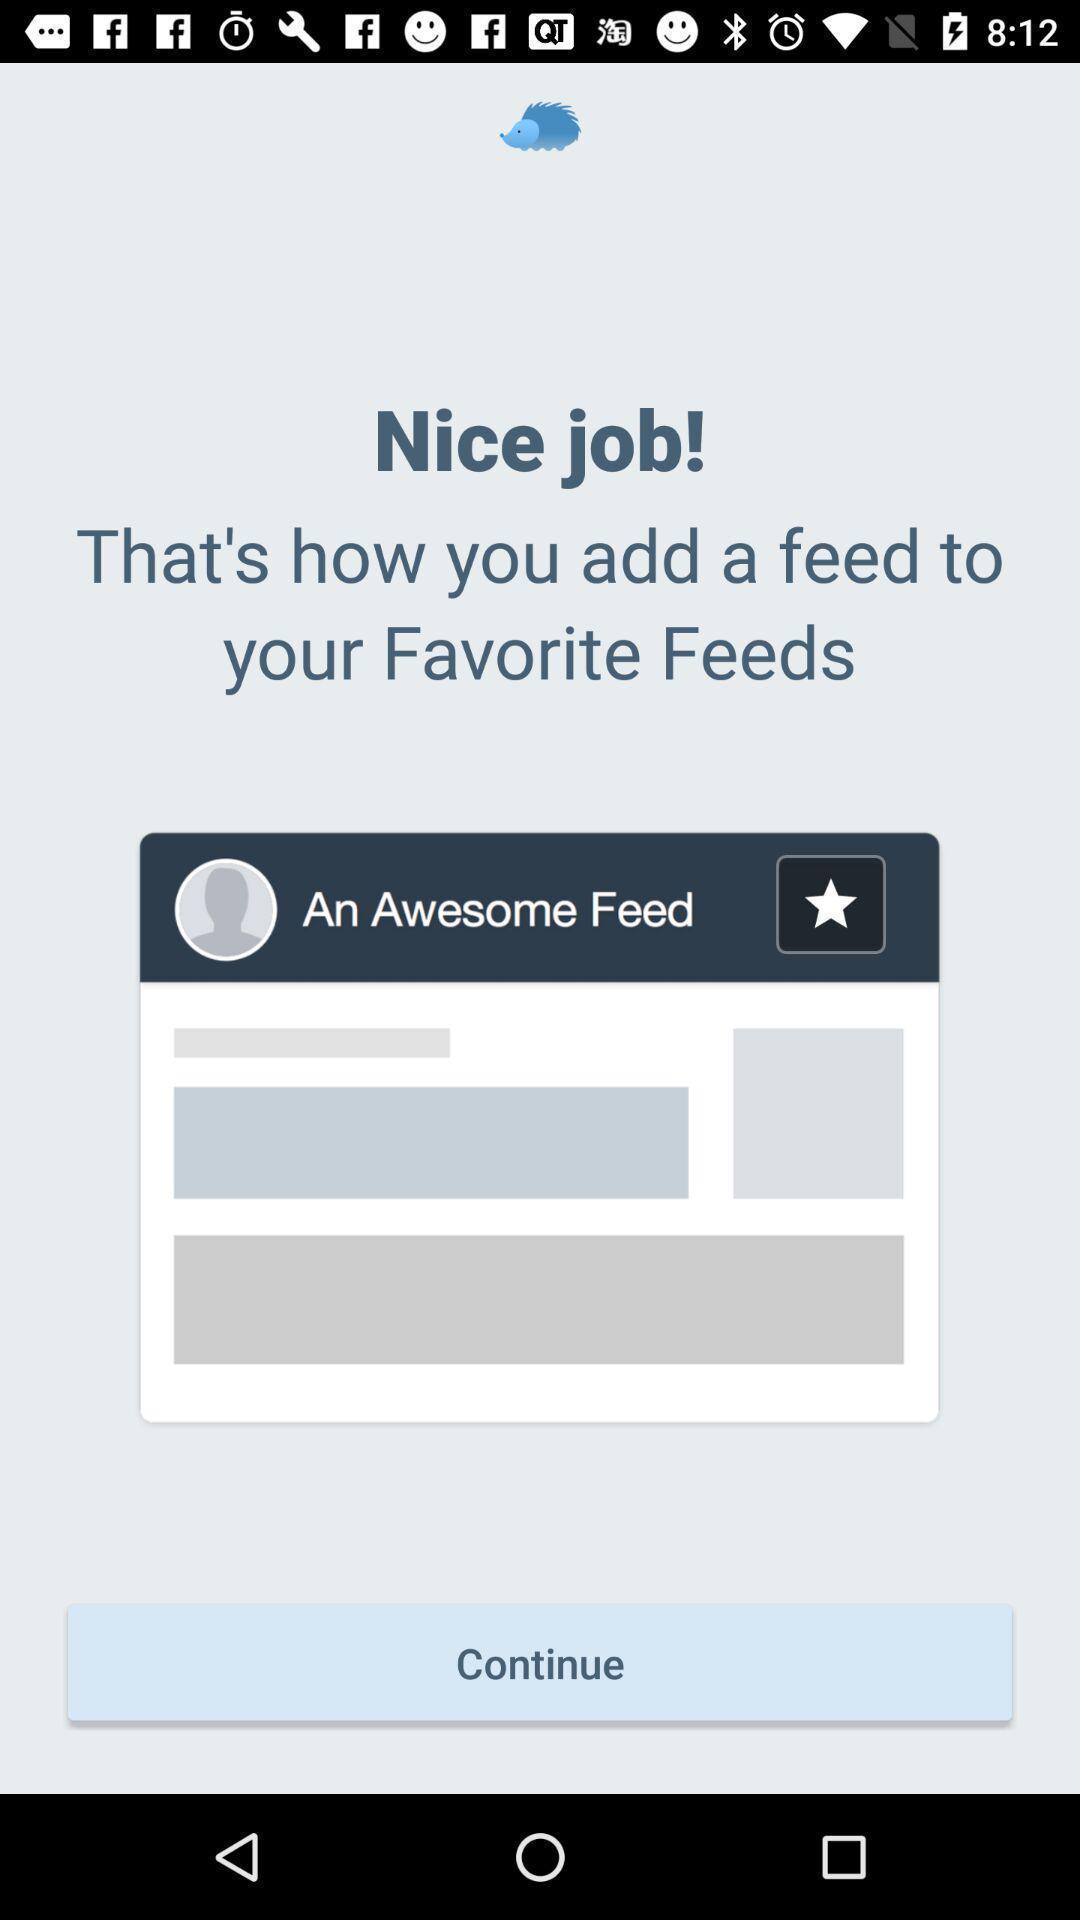Please provide a description for this image. Page showing feed back about adding feed. 